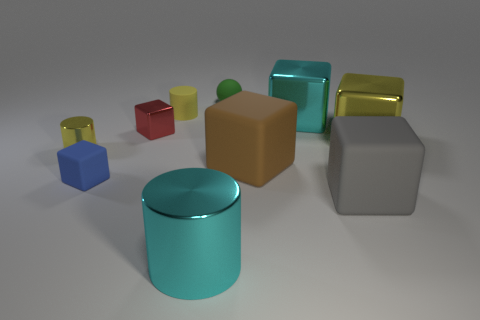Subtract all brown cubes. How many cubes are left? 5 Subtract all brown blocks. How many blocks are left? 5 Subtract all cubes. How many objects are left? 4 Subtract 1 cylinders. How many cylinders are left? 2 Subtract all brown cubes. Subtract all cyan cylinders. How many cubes are left? 5 Subtract all cyan blocks. How many yellow cylinders are left? 2 Subtract all blue rubber blocks. Subtract all shiny objects. How many objects are left? 4 Add 8 green rubber things. How many green rubber things are left? 9 Add 4 small shiny things. How many small shiny things exist? 6 Subtract 1 cyan cubes. How many objects are left? 9 